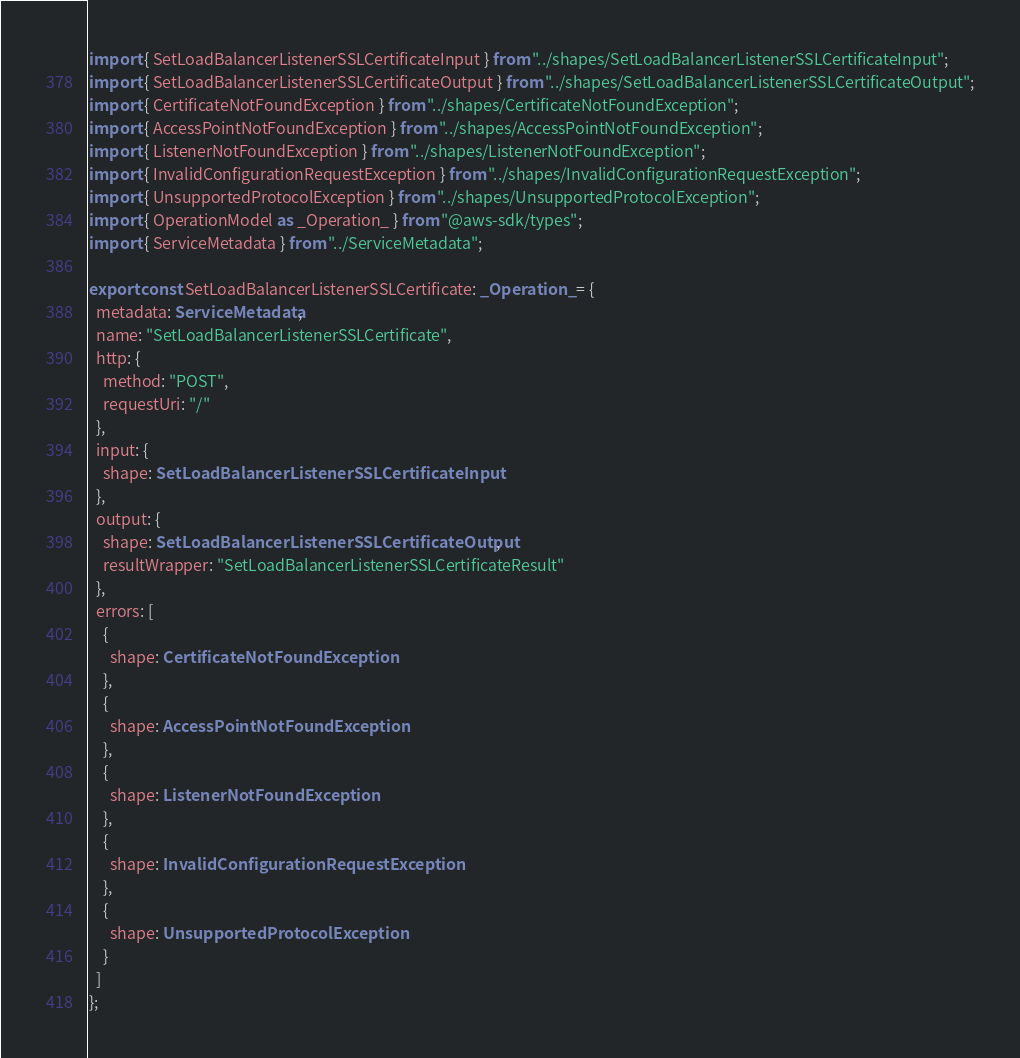<code> <loc_0><loc_0><loc_500><loc_500><_TypeScript_>import { SetLoadBalancerListenerSSLCertificateInput } from "../shapes/SetLoadBalancerListenerSSLCertificateInput";
import { SetLoadBalancerListenerSSLCertificateOutput } from "../shapes/SetLoadBalancerListenerSSLCertificateOutput";
import { CertificateNotFoundException } from "../shapes/CertificateNotFoundException";
import { AccessPointNotFoundException } from "../shapes/AccessPointNotFoundException";
import { ListenerNotFoundException } from "../shapes/ListenerNotFoundException";
import { InvalidConfigurationRequestException } from "../shapes/InvalidConfigurationRequestException";
import { UnsupportedProtocolException } from "../shapes/UnsupportedProtocolException";
import { OperationModel as _Operation_ } from "@aws-sdk/types";
import { ServiceMetadata } from "../ServiceMetadata";

export const SetLoadBalancerListenerSSLCertificate: _Operation_ = {
  metadata: ServiceMetadata,
  name: "SetLoadBalancerListenerSSLCertificate",
  http: {
    method: "POST",
    requestUri: "/"
  },
  input: {
    shape: SetLoadBalancerListenerSSLCertificateInput
  },
  output: {
    shape: SetLoadBalancerListenerSSLCertificateOutput,
    resultWrapper: "SetLoadBalancerListenerSSLCertificateResult"
  },
  errors: [
    {
      shape: CertificateNotFoundException
    },
    {
      shape: AccessPointNotFoundException
    },
    {
      shape: ListenerNotFoundException
    },
    {
      shape: InvalidConfigurationRequestException
    },
    {
      shape: UnsupportedProtocolException
    }
  ]
};
</code> 